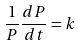<formula> <loc_0><loc_0><loc_500><loc_500>\frac { 1 } { P } \frac { d P } { d t } = k</formula> 